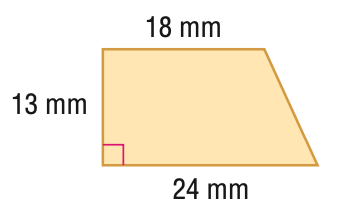Question: Find the area of the trapezoid.
Choices:
A. 234
B. 273
C. 286
D. 312
Answer with the letter. Answer: B 